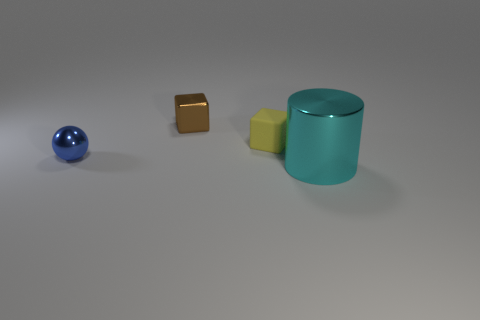How many cyan metallic cylinders are there?
Ensure brevity in your answer.  1. There is a shiny thing that is both in front of the small yellow object and to the left of the tiny yellow rubber thing; what is its color?
Offer a terse response. Blue. There is another thing that is the same shape as the small brown shiny object; what size is it?
Offer a terse response. Small. What number of yellow things have the same size as the blue object?
Your answer should be compact. 1. What material is the tiny brown object?
Provide a succinct answer. Metal. Are there any brown cubes on the right side of the metal cylinder?
Make the answer very short. No. What size is the block that is the same material as the tiny ball?
Provide a succinct answer. Small. How many matte objects are the same color as the large metallic cylinder?
Keep it short and to the point. 0. Is the number of tiny brown metallic blocks in front of the matte object less than the number of matte blocks to the right of the cyan object?
Your answer should be compact. No. What size is the thing that is in front of the blue sphere?
Make the answer very short. Large. 